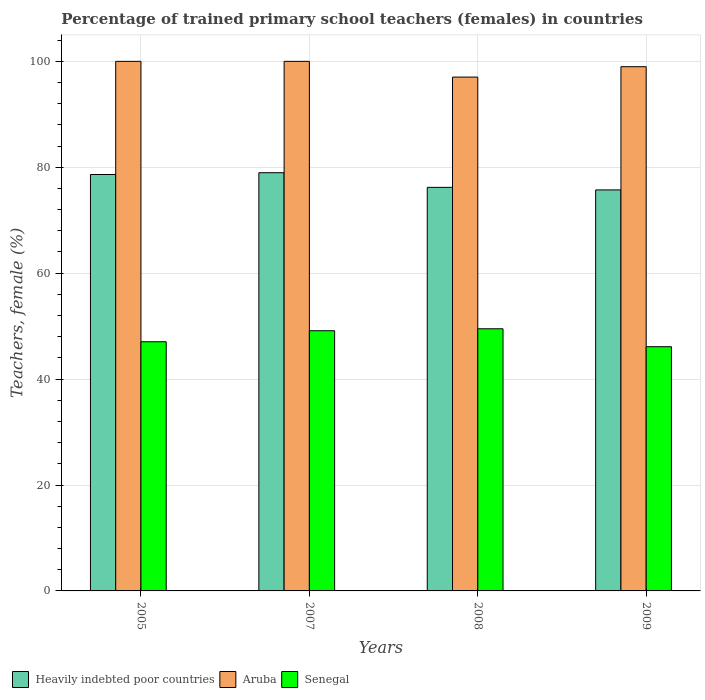How many groups of bars are there?
Provide a short and direct response. 4. Are the number of bars per tick equal to the number of legend labels?
Ensure brevity in your answer.  Yes. What is the label of the 4th group of bars from the left?
Offer a terse response. 2009. What is the percentage of trained primary school teachers (females) in Aruba in 2009?
Your response must be concise. 98.99. Across all years, what is the minimum percentage of trained primary school teachers (females) in Aruba?
Provide a succinct answer. 97.03. In which year was the percentage of trained primary school teachers (females) in Heavily indebted poor countries maximum?
Offer a very short reply. 2007. In which year was the percentage of trained primary school teachers (females) in Heavily indebted poor countries minimum?
Offer a terse response. 2009. What is the total percentage of trained primary school teachers (females) in Heavily indebted poor countries in the graph?
Ensure brevity in your answer.  309.53. What is the difference between the percentage of trained primary school teachers (females) in Senegal in 2005 and that in 2007?
Keep it short and to the point. -2.08. What is the difference between the percentage of trained primary school teachers (females) in Senegal in 2008 and the percentage of trained primary school teachers (females) in Heavily indebted poor countries in 2009?
Offer a very short reply. -26.22. What is the average percentage of trained primary school teachers (females) in Senegal per year?
Offer a very short reply. 47.95. In the year 2007, what is the difference between the percentage of trained primary school teachers (females) in Aruba and percentage of trained primary school teachers (females) in Heavily indebted poor countries?
Give a very brief answer. 21.03. What is the ratio of the percentage of trained primary school teachers (females) in Aruba in 2007 to that in 2009?
Your answer should be very brief. 1.01. Is the percentage of trained primary school teachers (females) in Heavily indebted poor countries in 2005 less than that in 2009?
Offer a terse response. No. What is the difference between the highest and the second highest percentage of trained primary school teachers (females) in Senegal?
Make the answer very short. 0.37. What is the difference between the highest and the lowest percentage of trained primary school teachers (females) in Aruba?
Give a very brief answer. 2.97. Is the sum of the percentage of trained primary school teachers (females) in Aruba in 2008 and 2009 greater than the maximum percentage of trained primary school teachers (females) in Senegal across all years?
Offer a terse response. Yes. What does the 1st bar from the left in 2008 represents?
Make the answer very short. Heavily indebted poor countries. What does the 3rd bar from the right in 2005 represents?
Give a very brief answer. Heavily indebted poor countries. Is it the case that in every year, the sum of the percentage of trained primary school teachers (females) in Aruba and percentage of trained primary school teachers (females) in Senegal is greater than the percentage of trained primary school teachers (females) in Heavily indebted poor countries?
Offer a terse response. Yes. How many bars are there?
Provide a short and direct response. 12. What is the difference between two consecutive major ticks on the Y-axis?
Offer a very short reply. 20. Are the values on the major ticks of Y-axis written in scientific E-notation?
Make the answer very short. No. Does the graph contain any zero values?
Provide a succinct answer. No. How are the legend labels stacked?
Offer a terse response. Horizontal. What is the title of the graph?
Keep it short and to the point. Percentage of trained primary school teachers (females) in countries. Does "Syrian Arab Republic" appear as one of the legend labels in the graph?
Keep it short and to the point. No. What is the label or title of the X-axis?
Make the answer very short. Years. What is the label or title of the Y-axis?
Offer a terse response. Teachers, female (%). What is the Teachers, female (%) of Heavily indebted poor countries in 2005?
Offer a terse response. 78.63. What is the Teachers, female (%) in Senegal in 2005?
Give a very brief answer. 47.05. What is the Teachers, female (%) in Heavily indebted poor countries in 2007?
Offer a terse response. 78.97. What is the Teachers, female (%) in Aruba in 2007?
Your answer should be very brief. 100. What is the Teachers, female (%) in Senegal in 2007?
Give a very brief answer. 49.13. What is the Teachers, female (%) of Heavily indebted poor countries in 2008?
Provide a short and direct response. 76.21. What is the Teachers, female (%) of Aruba in 2008?
Keep it short and to the point. 97.03. What is the Teachers, female (%) of Senegal in 2008?
Your answer should be very brief. 49.5. What is the Teachers, female (%) of Heavily indebted poor countries in 2009?
Offer a very short reply. 75.72. What is the Teachers, female (%) in Aruba in 2009?
Provide a succinct answer. 98.99. What is the Teachers, female (%) of Senegal in 2009?
Your answer should be very brief. 46.11. Across all years, what is the maximum Teachers, female (%) in Heavily indebted poor countries?
Provide a short and direct response. 78.97. Across all years, what is the maximum Teachers, female (%) of Senegal?
Keep it short and to the point. 49.5. Across all years, what is the minimum Teachers, female (%) of Heavily indebted poor countries?
Your response must be concise. 75.72. Across all years, what is the minimum Teachers, female (%) in Aruba?
Your answer should be very brief. 97.03. Across all years, what is the minimum Teachers, female (%) in Senegal?
Your answer should be compact. 46.11. What is the total Teachers, female (%) of Heavily indebted poor countries in the graph?
Your answer should be very brief. 309.53. What is the total Teachers, female (%) of Aruba in the graph?
Provide a succinct answer. 396.02. What is the total Teachers, female (%) of Senegal in the graph?
Make the answer very short. 191.8. What is the difference between the Teachers, female (%) in Heavily indebted poor countries in 2005 and that in 2007?
Make the answer very short. -0.34. What is the difference between the Teachers, female (%) of Aruba in 2005 and that in 2007?
Keep it short and to the point. 0. What is the difference between the Teachers, female (%) in Senegal in 2005 and that in 2007?
Your answer should be very brief. -2.08. What is the difference between the Teachers, female (%) of Heavily indebted poor countries in 2005 and that in 2008?
Give a very brief answer. 2.43. What is the difference between the Teachers, female (%) in Aruba in 2005 and that in 2008?
Your answer should be compact. 2.97. What is the difference between the Teachers, female (%) of Senegal in 2005 and that in 2008?
Your answer should be compact. -2.45. What is the difference between the Teachers, female (%) in Heavily indebted poor countries in 2005 and that in 2009?
Ensure brevity in your answer.  2.91. What is the difference between the Teachers, female (%) of Senegal in 2005 and that in 2009?
Keep it short and to the point. 0.93. What is the difference between the Teachers, female (%) in Heavily indebted poor countries in 2007 and that in 2008?
Provide a short and direct response. 2.76. What is the difference between the Teachers, female (%) of Aruba in 2007 and that in 2008?
Your response must be concise. 2.97. What is the difference between the Teachers, female (%) of Senegal in 2007 and that in 2008?
Your answer should be compact. -0.37. What is the difference between the Teachers, female (%) in Heavily indebted poor countries in 2007 and that in 2009?
Offer a terse response. 3.25. What is the difference between the Teachers, female (%) of Senegal in 2007 and that in 2009?
Make the answer very short. 3.02. What is the difference between the Teachers, female (%) in Heavily indebted poor countries in 2008 and that in 2009?
Offer a very short reply. 0.48. What is the difference between the Teachers, female (%) of Aruba in 2008 and that in 2009?
Make the answer very short. -1.96. What is the difference between the Teachers, female (%) in Senegal in 2008 and that in 2009?
Your answer should be very brief. 3.39. What is the difference between the Teachers, female (%) in Heavily indebted poor countries in 2005 and the Teachers, female (%) in Aruba in 2007?
Provide a succinct answer. -21.37. What is the difference between the Teachers, female (%) in Heavily indebted poor countries in 2005 and the Teachers, female (%) in Senegal in 2007?
Provide a short and direct response. 29.5. What is the difference between the Teachers, female (%) of Aruba in 2005 and the Teachers, female (%) of Senegal in 2007?
Keep it short and to the point. 50.87. What is the difference between the Teachers, female (%) of Heavily indebted poor countries in 2005 and the Teachers, female (%) of Aruba in 2008?
Offer a terse response. -18.4. What is the difference between the Teachers, female (%) of Heavily indebted poor countries in 2005 and the Teachers, female (%) of Senegal in 2008?
Your answer should be very brief. 29.13. What is the difference between the Teachers, female (%) of Aruba in 2005 and the Teachers, female (%) of Senegal in 2008?
Your answer should be compact. 50.5. What is the difference between the Teachers, female (%) in Heavily indebted poor countries in 2005 and the Teachers, female (%) in Aruba in 2009?
Give a very brief answer. -20.36. What is the difference between the Teachers, female (%) of Heavily indebted poor countries in 2005 and the Teachers, female (%) of Senegal in 2009?
Offer a terse response. 32.52. What is the difference between the Teachers, female (%) in Aruba in 2005 and the Teachers, female (%) in Senegal in 2009?
Provide a succinct answer. 53.89. What is the difference between the Teachers, female (%) of Heavily indebted poor countries in 2007 and the Teachers, female (%) of Aruba in 2008?
Give a very brief answer. -18.06. What is the difference between the Teachers, female (%) of Heavily indebted poor countries in 2007 and the Teachers, female (%) of Senegal in 2008?
Your answer should be very brief. 29.47. What is the difference between the Teachers, female (%) of Aruba in 2007 and the Teachers, female (%) of Senegal in 2008?
Offer a terse response. 50.5. What is the difference between the Teachers, female (%) of Heavily indebted poor countries in 2007 and the Teachers, female (%) of Aruba in 2009?
Provide a short and direct response. -20.02. What is the difference between the Teachers, female (%) in Heavily indebted poor countries in 2007 and the Teachers, female (%) in Senegal in 2009?
Your answer should be compact. 32.86. What is the difference between the Teachers, female (%) of Aruba in 2007 and the Teachers, female (%) of Senegal in 2009?
Provide a short and direct response. 53.89. What is the difference between the Teachers, female (%) of Heavily indebted poor countries in 2008 and the Teachers, female (%) of Aruba in 2009?
Provide a succinct answer. -22.78. What is the difference between the Teachers, female (%) of Heavily indebted poor countries in 2008 and the Teachers, female (%) of Senegal in 2009?
Your answer should be compact. 30.09. What is the difference between the Teachers, female (%) of Aruba in 2008 and the Teachers, female (%) of Senegal in 2009?
Make the answer very short. 50.92. What is the average Teachers, female (%) of Heavily indebted poor countries per year?
Keep it short and to the point. 77.38. What is the average Teachers, female (%) of Aruba per year?
Make the answer very short. 99. What is the average Teachers, female (%) in Senegal per year?
Provide a succinct answer. 47.95. In the year 2005, what is the difference between the Teachers, female (%) in Heavily indebted poor countries and Teachers, female (%) in Aruba?
Provide a short and direct response. -21.37. In the year 2005, what is the difference between the Teachers, female (%) in Heavily indebted poor countries and Teachers, female (%) in Senegal?
Offer a very short reply. 31.58. In the year 2005, what is the difference between the Teachers, female (%) in Aruba and Teachers, female (%) in Senegal?
Offer a terse response. 52.95. In the year 2007, what is the difference between the Teachers, female (%) in Heavily indebted poor countries and Teachers, female (%) in Aruba?
Offer a terse response. -21.03. In the year 2007, what is the difference between the Teachers, female (%) in Heavily indebted poor countries and Teachers, female (%) in Senegal?
Offer a terse response. 29.84. In the year 2007, what is the difference between the Teachers, female (%) in Aruba and Teachers, female (%) in Senegal?
Provide a succinct answer. 50.87. In the year 2008, what is the difference between the Teachers, female (%) of Heavily indebted poor countries and Teachers, female (%) of Aruba?
Provide a short and direct response. -20.82. In the year 2008, what is the difference between the Teachers, female (%) in Heavily indebted poor countries and Teachers, female (%) in Senegal?
Give a very brief answer. 26.7. In the year 2008, what is the difference between the Teachers, female (%) in Aruba and Teachers, female (%) in Senegal?
Your response must be concise. 47.53. In the year 2009, what is the difference between the Teachers, female (%) of Heavily indebted poor countries and Teachers, female (%) of Aruba?
Offer a very short reply. -23.27. In the year 2009, what is the difference between the Teachers, female (%) of Heavily indebted poor countries and Teachers, female (%) of Senegal?
Ensure brevity in your answer.  29.61. In the year 2009, what is the difference between the Teachers, female (%) of Aruba and Teachers, female (%) of Senegal?
Keep it short and to the point. 52.88. What is the ratio of the Teachers, female (%) of Senegal in 2005 to that in 2007?
Your answer should be compact. 0.96. What is the ratio of the Teachers, female (%) in Heavily indebted poor countries in 2005 to that in 2008?
Provide a short and direct response. 1.03. What is the ratio of the Teachers, female (%) of Aruba in 2005 to that in 2008?
Offer a very short reply. 1.03. What is the ratio of the Teachers, female (%) of Senegal in 2005 to that in 2008?
Your answer should be compact. 0.95. What is the ratio of the Teachers, female (%) of Heavily indebted poor countries in 2005 to that in 2009?
Your answer should be compact. 1.04. What is the ratio of the Teachers, female (%) of Aruba in 2005 to that in 2009?
Provide a succinct answer. 1.01. What is the ratio of the Teachers, female (%) in Senegal in 2005 to that in 2009?
Your answer should be very brief. 1.02. What is the ratio of the Teachers, female (%) of Heavily indebted poor countries in 2007 to that in 2008?
Your response must be concise. 1.04. What is the ratio of the Teachers, female (%) of Aruba in 2007 to that in 2008?
Give a very brief answer. 1.03. What is the ratio of the Teachers, female (%) of Heavily indebted poor countries in 2007 to that in 2009?
Ensure brevity in your answer.  1.04. What is the ratio of the Teachers, female (%) in Aruba in 2007 to that in 2009?
Ensure brevity in your answer.  1.01. What is the ratio of the Teachers, female (%) of Senegal in 2007 to that in 2009?
Your response must be concise. 1.07. What is the ratio of the Teachers, female (%) in Heavily indebted poor countries in 2008 to that in 2009?
Your response must be concise. 1.01. What is the ratio of the Teachers, female (%) of Aruba in 2008 to that in 2009?
Ensure brevity in your answer.  0.98. What is the ratio of the Teachers, female (%) of Senegal in 2008 to that in 2009?
Ensure brevity in your answer.  1.07. What is the difference between the highest and the second highest Teachers, female (%) in Heavily indebted poor countries?
Provide a succinct answer. 0.34. What is the difference between the highest and the second highest Teachers, female (%) in Senegal?
Your answer should be very brief. 0.37. What is the difference between the highest and the lowest Teachers, female (%) of Heavily indebted poor countries?
Offer a terse response. 3.25. What is the difference between the highest and the lowest Teachers, female (%) in Aruba?
Your answer should be compact. 2.97. What is the difference between the highest and the lowest Teachers, female (%) of Senegal?
Ensure brevity in your answer.  3.39. 